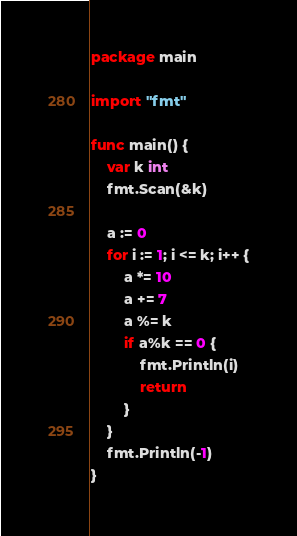Convert code to text. <code><loc_0><loc_0><loc_500><loc_500><_Go_>package main

import "fmt"

func main() {
	var k int
	fmt.Scan(&k)

	a := 0
	for i := 1; i <= k; i++ {
		a *= 10
		a += 7
		a %= k
		if a%k == 0 {
			fmt.Println(i)
			return
		}
	}
	fmt.Println(-1)
}
</code> 